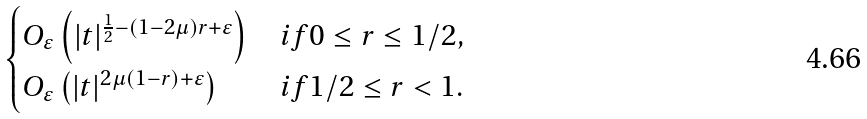Convert formula to latex. <formula><loc_0><loc_0><loc_500><loc_500>\begin{cases} O _ { \varepsilon } \left ( | t | ^ { \frac { 1 } { 2 } - ( 1 - 2 \mu ) r + \varepsilon } \right ) & i f 0 \leq r \leq 1 / 2 , \\ O _ { \varepsilon } \left ( | t | ^ { 2 \mu ( 1 - r ) + \varepsilon } \right ) & i f 1 / 2 \leq r < 1 . \end{cases}</formula> 